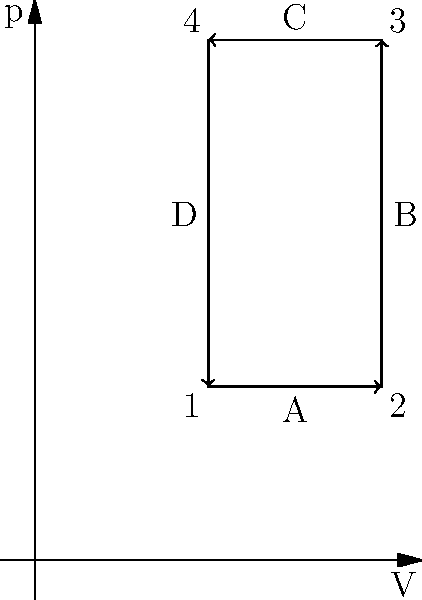Consider the pressure-volume (p-V) diagram of a heat engine cycle shown above. The cycle consists of four processes: 1-2 (isothermal expansion), 2-3 (isochoric heating), 3-4 (isothermal compression), and 4-1 (isochoric cooling). If the heat input during the isochoric heating process (2-3) is 600 J, calculate the efficiency of this heat engine. How does this efficiency compare to the Carnot efficiency between the same temperature extremes? To solve this problem, we'll follow these steps:

1) First, we need to calculate the work done by the system, which is the area enclosed by the p-V diagram.

   Area = Area of rectangle ABCD
   
   $W = (V_2 - V_1)(p_3 - p_1) = (2 - 1)(3 - 1) = 2$ units

2) Each unit in the p-V diagram represents 100 J, so the total work done is:

   $W = 2 * 100 = 200$ J

3) The efficiency of a heat engine is given by:

   $\eta = \frac{W}{Q_{in}}$

   Where $W$ is the work done and $Q_{in}$ is the heat input.

4) We know that $Q_{in}$ during the isochoric heating (2-3) is 600 J. However, there's also heat input during the isothermal expansion (1-2).

5) For an isothermal process, $Q = W$. The work done during 1-2 is:

   $W_{1-2} = p_1(V_2 - V_1) = 1 * (2 - 1) * 100 = 100$ J

6) So, the total heat input is:

   $Q_{in} = 600 + 100 = 700$ J

7) Now we can calculate the efficiency:

   $\eta = \frac{200}{700} = \frac{2}{7} \approx 0.2857$ or 28.57%

8) To compare with Carnot efficiency, we need the temperature ratio:

   $\frac{T_{hot}}{T_{cold}} = \frac{p_3}{p_1} = 3$

9) Carnot efficiency is given by:

   $\eta_{Carnot} = 1 - \frac{T_{cold}}{T_{hot}} = 1 - \frac{1}{3} = \frac{2}{3} \approx 0.6667$ or 66.67%

10) The actual efficiency (28.57%) is less than the Carnot efficiency (66.67%) for the same temperature extremes, which is expected as the Carnot cycle is the most efficient possible cycle between two temperature reservoirs.
Answer: 28.57%; lower than Carnot efficiency (66.67%) 